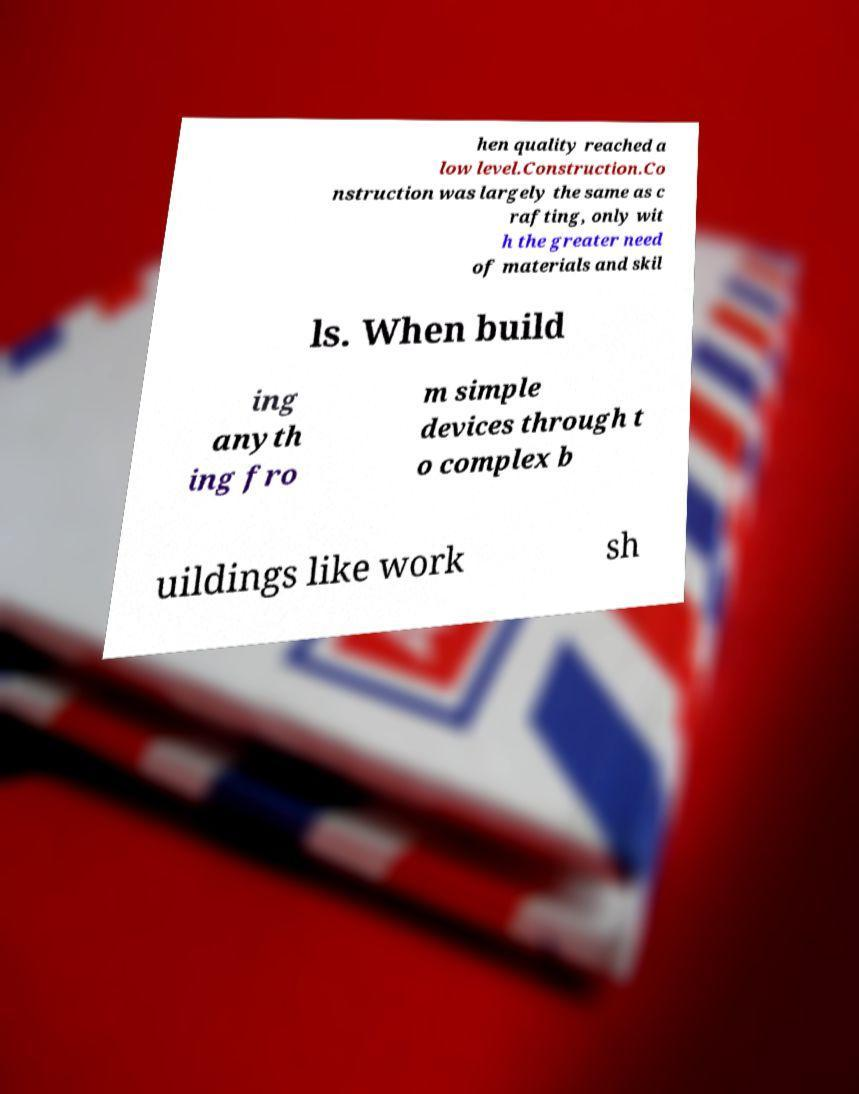For documentation purposes, I need the text within this image transcribed. Could you provide that? hen quality reached a low level.Construction.Co nstruction was largely the same as c rafting, only wit h the greater need of materials and skil ls. When build ing anyth ing fro m simple devices through t o complex b uildings like work sh 